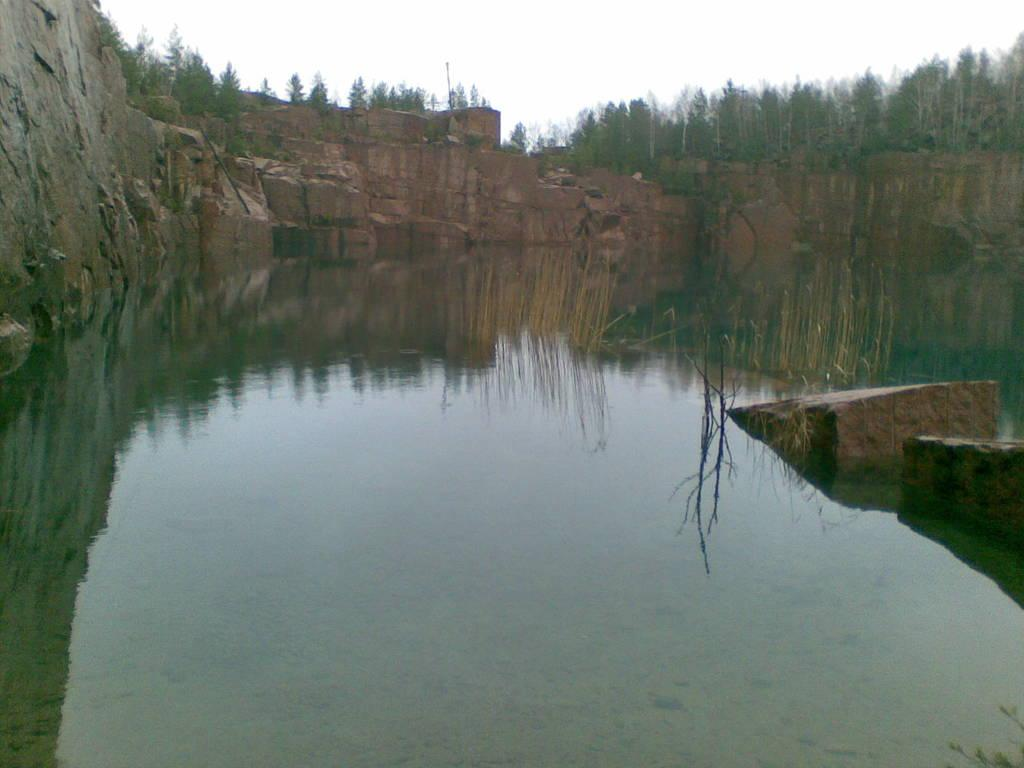What type of structure is present in the image? There is a rock wall in the image. What other natural elements can be seen in the image? There are trees and water visible in the image. How would you describe the sky in the image? The sky appears to be white in color. Can you see the man's hand holding the stem of the tree in the image? There is no man or stem of a tree present in the image. 